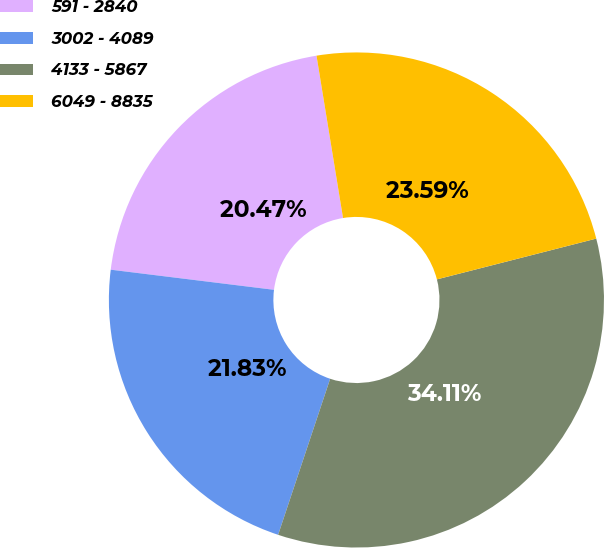Convert chart. <chart><loc_0><loc_0><loc_500><loc_500><pie_chart><fcel>591 - 2840<fcel>3002 - 4089<fcel>4133 - 5867<fcel>6049 - 8835<nl><fcel>20.47%<fcel>21.83%<fcel>34.11%<fcel>23.59%<nl></chart> 